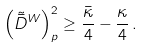<formula> <loc_0><loc_0><loc_500><loc_500>\left ( \tilde { \bar { D } } ^ { W } \right ) _ { p } ^ { 2 } \geq \frac { \bar { \kappa } } 4 - \frac { \kappa } { 4 } \, .</formula> 